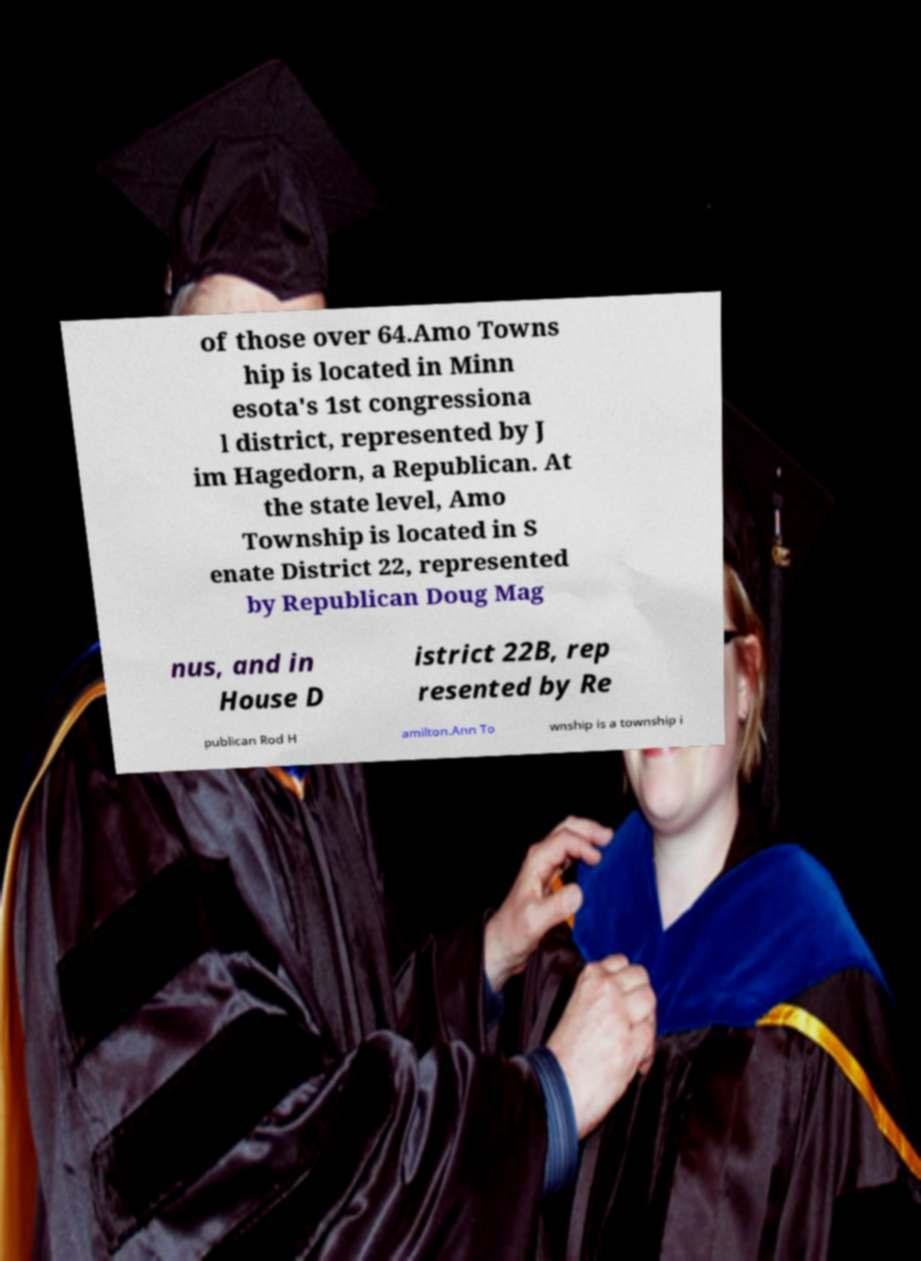What messages or text are displayed in this image? I need them in a readable, typed format. of those over 64.Amo Towns hip is located in Minn esota's 1st congressiona l district, represented by J im Hagedorn, a Republican. At the state level, Amo Township is located in S enate District 22, represented by Republican Doug Mag nus, and in House D istrict 22B, rep resented by Re publican Rod H amilton.Ann To wnship is a township i 